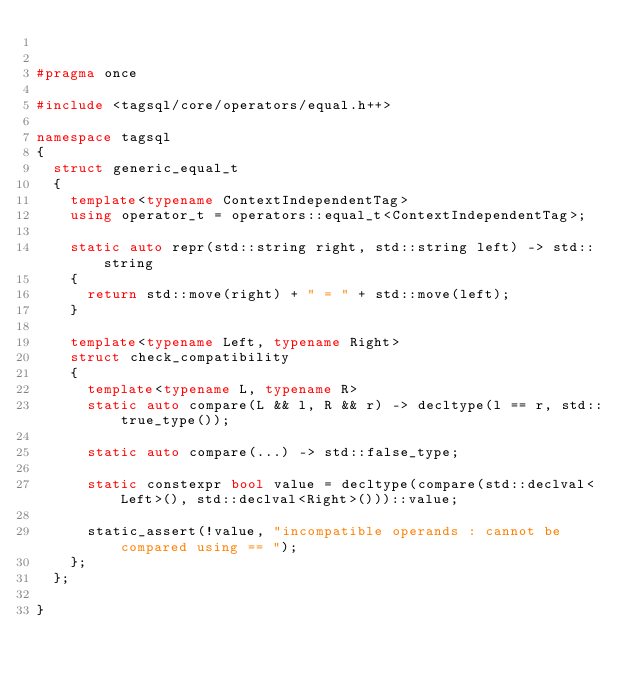<code> <loc_0><loc_0><loc_500><loc_500><_C++_>

#pragma once

#include <tagsql/core/operators/equal.h++>

namespace tagsql
{
	struct generic_equal_t
	{
		template<typename ContextIndependentTag>
		using operator_t = operators::equal_t<ContextIndependentTag>;

		static auto repr(std::string right, std::string left) -> std::string
		{
			return std::move(right) + " = " + std::move(left);
		}

		template<typename Left, typename Right>
		struct check_compatibility
		{
			template<typename L, typename R>
			static auto compare(L && l, R && r) -> decltype(l == r, std::true_type()); 

			static auto compare(...) -> std::false_type;

			static constexpr bool value = decltype(compare(std::declval<Left>(), std::declval<Right>()))::value;

			static_assert(!value, "incompatible operands : cannot be compared using == ");
		};
	};

}
</code> 